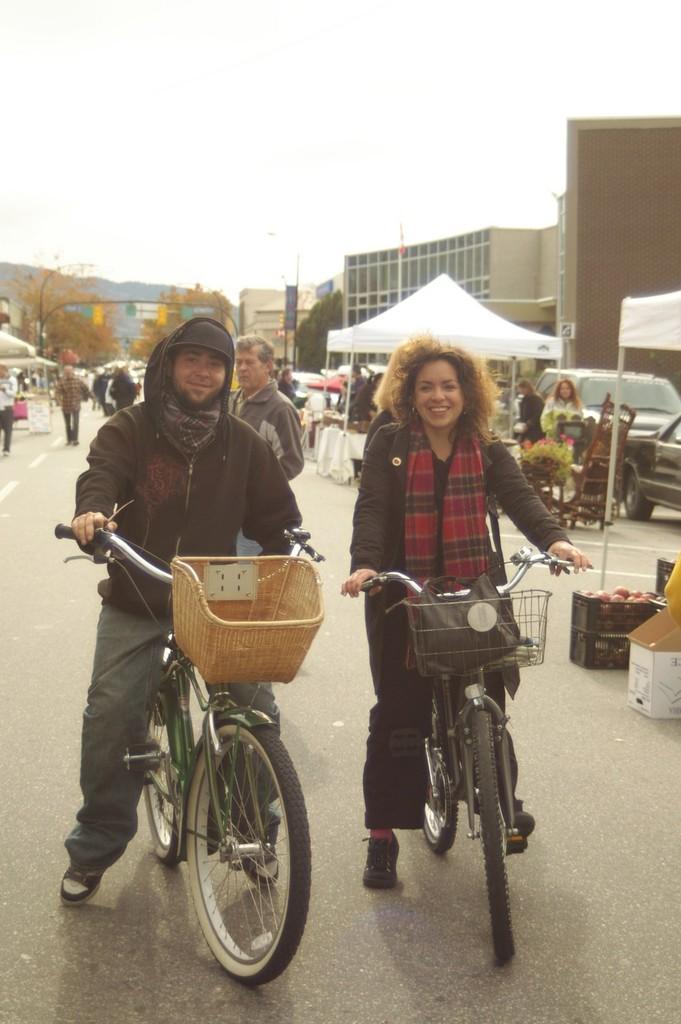Please provide a concise description of this image. There are two people in the image man and woman in which both man and woman are riding a bicycle inside woman basket we can see a carry bag. Beside woman we can see fruits inside the baskets. On right side we can see two cars and tent and group of people who are walking on road. There are some trees on both right side and left side, on right side we can see street light,building,mountains on both right and left side and sky on top. 